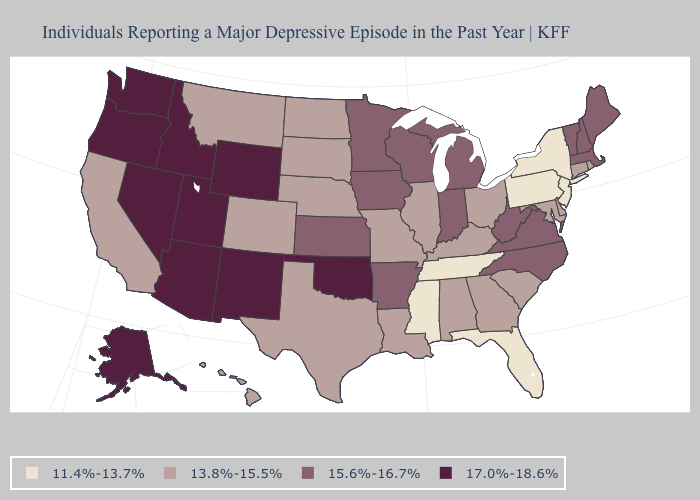Name the states that have a value in the range 13.8%-15.5%?
Quick response, please. Alabama, California, Colorado, Connecticut, Delaware, Georgia, Hawaii, Illinois, Kentucky, Louisiana, Maryland, Missouri, Montana, Nebraska, North Dakota, Ohio, Rhode Island, South Carolina, South Dakota, Texas. Does South Dakota have the highest value in the MidWest?
Answer briefly. No. What is the lowest value in the MidWest?
Concise answer only. 13.8%-15.5%. Does Colorado have the same value as Delaware?
Keep it brief. Yes. Which states hav the highest value in the South?
Short answer required. Oklahoma. Name the states that have a value in the range 13.8%-15.5%?
Quick response, please. Alabama, California, Colorado, Connecticut, Delaware, Georgia, Hawaii, Illinois, Kentucky, Louisiana, Maryland, Missouri, Montana, Nebraska, North Dakota, Ohio, Rhode Island, South Carolina, South Dakota, Texas. Does Oklahoma have a lower value than Minnesota?
Answer briefly. No. What is the value of Louisiana?
Quick response, please. 13.8%-15.5%. Among the states that border Arkansas , which have the highest value?
Write a very short answer. Oklahoma. What is the lowest value in the MidWest?
Keep it brief. 13.8%-15.5%. Does Washington have the highest value in the West?
Keep it brief. Yes. What is the value of Wisconsin?
Quick response, please. 15.6%-16.7%. Does the first symbol in the legend represent the smallest category?
Quick response, please. Yes. Does Texas have the same value as Wyoming?
Quick response, please. No. Does Louisiana have a lower value than Virginia?
Quick response, please. Yes. 